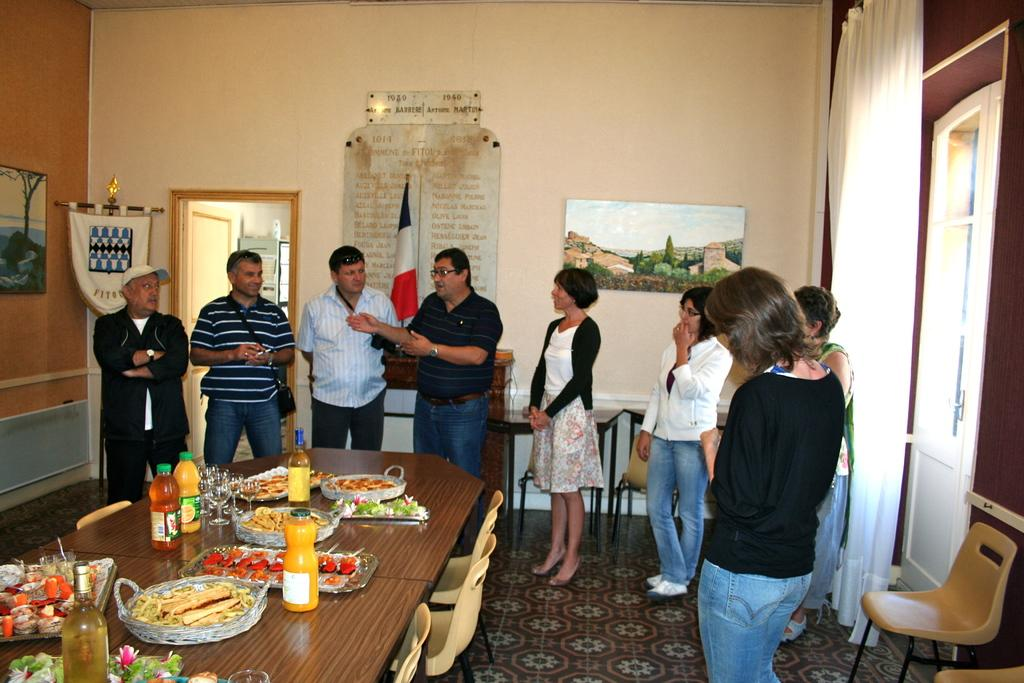How many people are in the image? There is a group of people in the image, but the exact number is not specified. What are the people doing in the image? The people are standing in the image. What can be seen on the table in the image? There are food items and bottles on the table in the image. What type of furniture is present in the image? There are chairs in the image. Can you see an airplane patch on any of the people's clothing in the image? There is no mention of an airplane patch or any specific clothing details in the image, so it cannot be determined if one is present. 